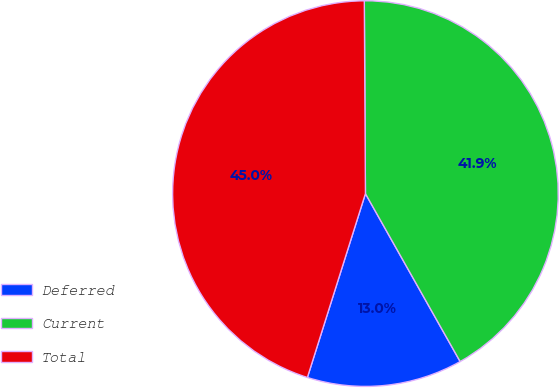Convert chart. <chart><loc_0><loc_0><loc_500><loc_500><pie_chart><fcel>Deferred<fcel>Current<fcel>Total<nl><fcel>13.04%<fcel>41.92%<fcel>45.04%<nl></chart> 